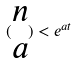<formula> <loc_0><loc_0><loc_500><loc_500>( \begin{matrix} n \\ a \end{matrix} ) < e ^ { a t }</formula> 